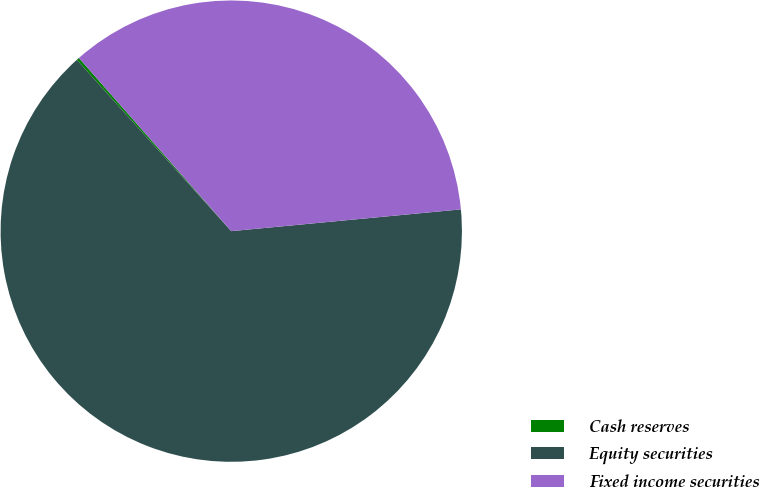<chart> <loc_0><loc_0><loc_500><loc_500><pie_chart><fcel>Cash reserves<fcel>Equity securities<fcel>Fixed income securities<nl><fcel>0.19%<fcel>64.83%<fcel>34.98%<nl></chart> 